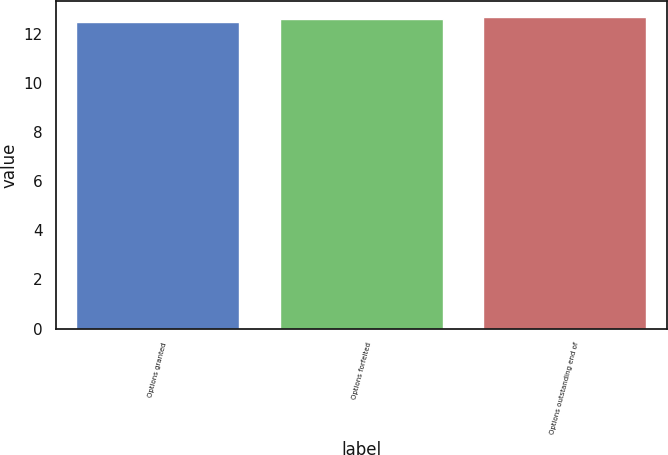<chart> <loc_0><loc_0><loc_500><loc_500><bar_chart><fcel>Options granted<fcel>Options forfeited<fcel>Options outstanding end of<nl><fcel>12.5<fcel>12.6<fcel>12.7<nl></chart> 